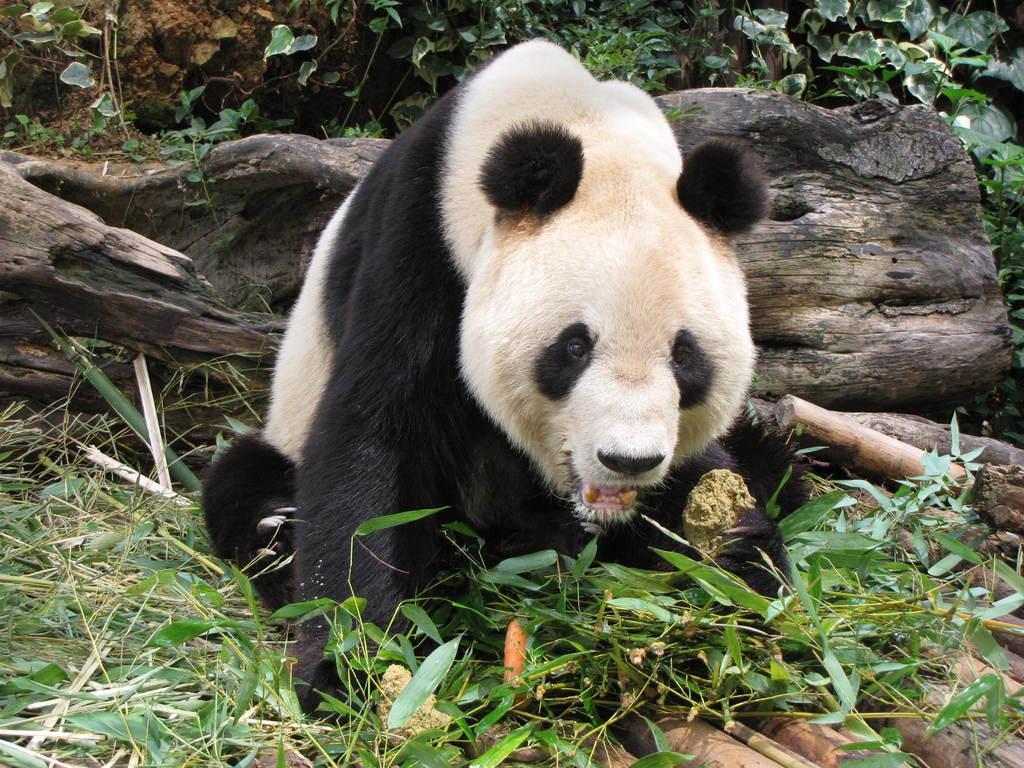Describe this image in one or two sentences. In this picture I can see a panda and I can see tree bark and few plants in the back and I can see grass on the ground. 